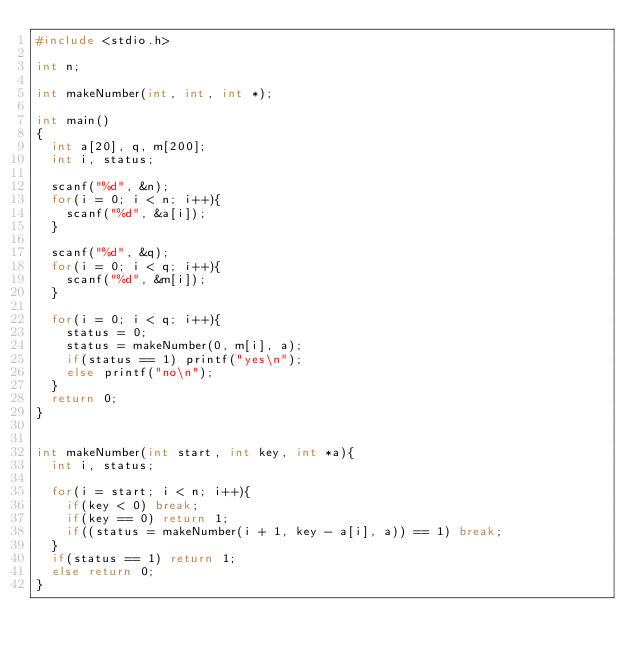Convert code to text. <code><loc_0><loc_0><loc_500><loc_500><_C_>#include <stdio.h>

int n;

int makeNumber(int, int, int *);

int main()
{
  int a[20], q, m[200];
  int i, status;

  scanf("%d", &n);
  for(i = 0; i < n; i++){
    scanf("%d", &a[i]);
  }
  
  scanf("%d", &q);
  for(i = 0; i < q; i++){
    scanf("%d", &m[i]);
  }
  
  for(i = 0; i < q; i++){
    status = 0;
    status = makeNumber(0, m[i], a);
    if(status == 1) printf("yes\n");
    else printf("no\n");
  }
  return 0;
}


int makeNumber(int start, int key, int *a){
  int i, status;
  
  for(i = start; i < n; i++){
    if(key < 0) break;
    if(key == 0) return 1;
    if((status = makeNumber(i + 1, key - a[i], a)) == 1) break;
  }
  if(status == 1) return 1;
  else return 0;
}

</code> 